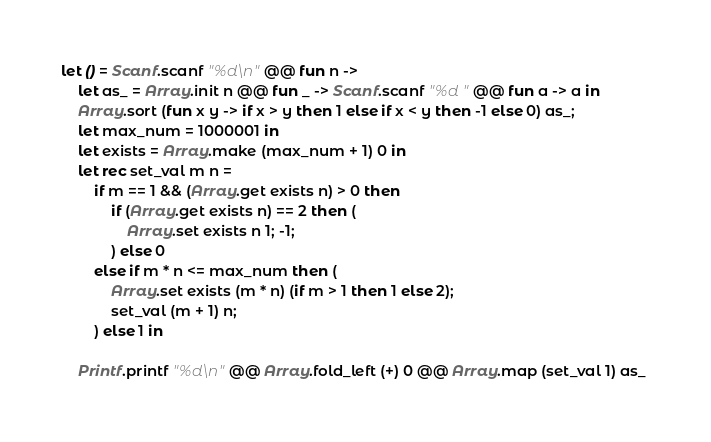Convert code to text. <code><loc_0><loc_0><loc_500><loc_500><_OCaml_>let () = Scanf.scanf "%d\n" @@ fun n ->
    let as_ = Array.init n @@ fun _ -> Scanf.scanf "%d " @@ fun a -> a in
    Array.sort (fun x y -> if x > y then 1 else if x < y then -1 else 0) as_;
    let max_num = 1000001 in
    let exists = Array.make (max_num + 1) 0 in
    let rec set_val m n =
        if m == 1 && (Array.get exists n) > 0 then
            if (Array.get exists n) == 2 then (
                Array.set exists n 1; -1;
            ) else 0
        else if m * n <= max_num then (
            Array.set exists (m * n) (if m > 1 then 1 else 2);
            set_val (m + 1) n;
        ) else 1 in

    Printf.printf "%d\n" @@ Array.fold_left (+) 0 @@ Array.map (set_val 1) as_ 

</code> 